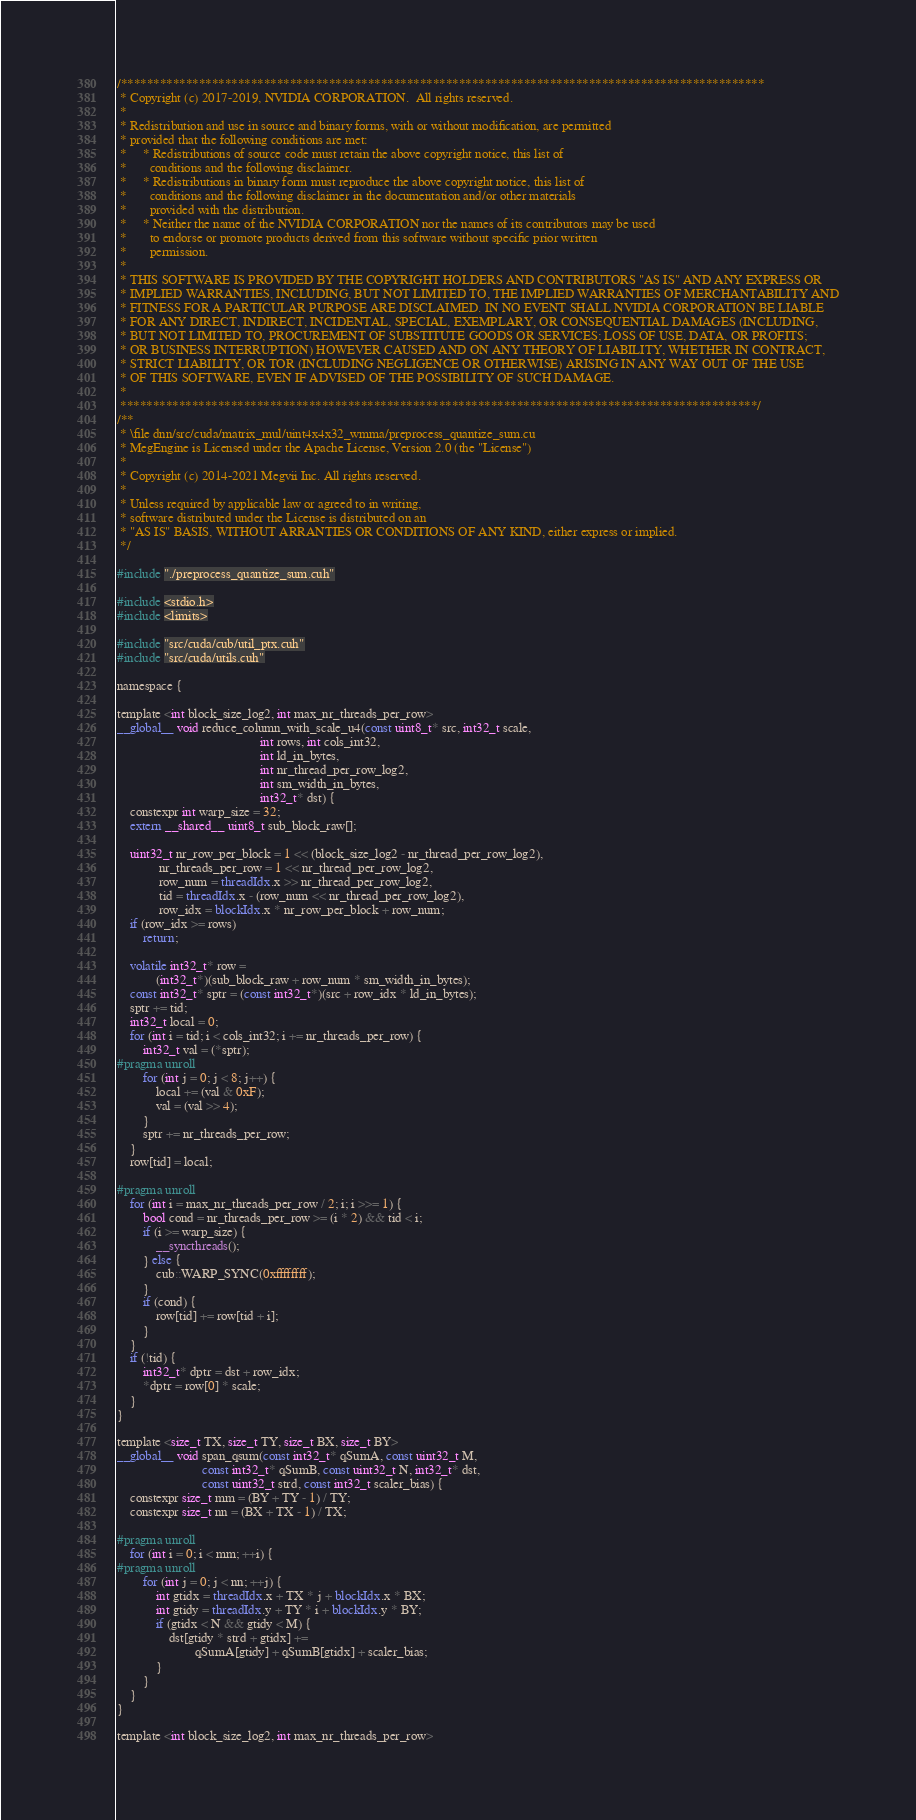<code> <loc_0><loc_0><loc_500><loc_500><_Cuda_>/***************************************************************************************************
 * Copyright (c) 2017-2019, NVIDIA CORPORATION.  All rights reserved.
 *
 * Redistribution and use in source and binary forms, with or without modification, are permitted
 * provided that the following conditions are met:
 *     * Redistributions of source code must retain the above copyright notice, this list of
 *       conditions and the following disclaimer.
 *     * Redistributions in binary form must reproduce the above copyright notice, this list of
 *       conditions and the following disclaimer in the documentation and/or other materials
 *       provided with the distribution.
 *     * Neither the name of the NVIDIA CORPORATION nor the names of its contributors may be used
 *       to endorse or promote products derived from this software without specific prior written
 *       permission.
 *
 * THIS SOFTWARE IS PROVIDED BY THE COPYRIGHT HOLDERS AND CONTRIBUTORS "AS IS" AND ANY EXPRESS OR
 * IMPLIED WARRANTIES, INCLUDING, BUT NOT LIMITED TO, THE IMPLIED WARRANTIES OF MERCHANTABILITY AND
 * FITNESS FOR A PARTICULAR PURPOSE ARE DISCLAIMED. IN NO EVENT SHALL NVIDIA CORPORATION BE LIABLE
 * FOR ANY DIRECT, INDIRECT, INCIDENTAL, SPECIAL, EXEMPLARY, OR CONSEQUENTIAL DAMAGES (INCLUDING,
 * BUT NOT LIMITED TO, PROCUREMENT OF SUBSTITUTE GOODS OR SERVICES; LOSS OF USE, DATA, OR PROFITS;
 * OR BUSINESS INTERRUPTION) HOWEVER CAUSED AND ON ANY THEORY OF LIABILITY, WHETHER IN CONTRACT,
 * STRICT LIABILITY, OR TOR (INCLUDING NEGLIGENCE OR OTHERWISE) ARISING IN ANY WAY OUT OF THE USE
 * OF THIS SOFTWARE, EVEN IF ADVISED OF THE POSSIBILITY OF SUCH DAMAGE.
 *
 **************************************************************************************************/
/**
 * \file dnn/src/cuda/matrix_mul/uint4x4x32_wmma/preprocess_quantize_sum.cu
 * MegEngine is Licensed under the Apache License, Version 2.0 (the "License")
 *
 * Copyright (c) 2014-2021 Megvii Inc. All rights reserved.
 *
 * Unless required by applicable law or agreed to in writing,
 * software distributed under the License is distributed on an
 * "AS IS" BASIS, WITHOUT ARRANTIES OR CONDITIONS OF ANY KIND, either express or implied.
 */

#include "./preprocess_quantize_sum.cuh"

#include <stdio.h>
#include <limits>

#include "src/cuda/cub/util_ptx.cuh"
#include "src/cuda/utils.cuh"

namespace {

template <int block_size_log2, int max_nr_threads_per_row>
__global__ void reduce_column_with_scale_u4(const uint8_t* src, int32_t scale,
                                            int rows, int cols_int32,
                                            int ld_in_bytes,
                                            int nr_thread_per_row_log2,
                                            int sm_width_in_bytes,
                                            int32_t* dst) {
    constexpr int warp_size = 32;
    extern __shared__ uint8_t sub_block_raw[];

    uint32_t nr_row_per_block = 1 << (block_size_log2 - nr_thread_per_row_log2),
             nr_threads_per_row = 1 << nr_thread_per_row_log2,
             row_num = threadIdx.x >> nr_thread_per_row_log2,
             tid = threadIdx.x - (row_num << nr_thread_per_row_log2),
             row_idx = blockIdx.x * nr_row_per_block + row_num;
    if (row_idx >= rows)
        return;

    volatile int32_t* row =
            (int32_t*)(sub_block_raw + row_num * sm_width_in_bytes);
    const int32_t* sptr = (const int32_t*)(src + row_idx * ld_in_bytes);
    sptr += tid;
    int32_t local = 0;
    for (int i = tid; i < cols_int32; i += nr_threads_per_row) {
        int32_t val = (*sptr);
#pragma unroll
        for (int j = 0; j < 8; j++) {
            local += (val & 0xF);
            val = (val >> 4);
        }
        sptr += nr_threads_per_row;
    }
    row[tid] = local;

#pragma unroll
    for (int i = max_nr_threads_per_row / 2; i; i >>= 1) {
        bool cond = nr_threads_per_row >= (i * 2) && tid < i;
        if (i >= warp_size) {
            __syncthreads();
        } else {
            cub::WARP_SYNC(0xffffffff);
        }
        if (cond) {
            row[tid] += row[tid + i];
        }
    }
    if (!tid) {
        int32_t* dptr = dst + row_idx;
        *dptr = row[0] * scale;
    }
}

template <size_t TX, size_t TY, size_t BX, size_t BY>
__global__ void span_qsum(const int32_t* qSumA, const uint32_t M,
                          const int32_t* qSumB, const uint32_t N, int32_t* dst,
                          const uint32_t strd, const int32_t scaler_bias) {
    constexpr size_t mm = (BY + TY - 1) / TY;
    constexpr size_t nn = (BX + TX - 1) / TX;

#pragma unroll
    for (int i = 0; i < mm; ++i) {
#pragma unroll
        for (int j = 0; j < nn; ++j) {
            int gtidx = threadIdx.x + TX * j + blockIdx.x * BX;
            int gtidy = threadIdx.y + TY * i + blockIdx.y * BY;
            if (gtidx < N && gtidy < M) {
                dst[gtidy * strd + gtidx] +=
                        qSumA[gtidy] + qSumB[gtidx] + scaler_bias;
            }
        }
    }
}

template <int block_size_log2, int max_nr_threads_per_row></code> 